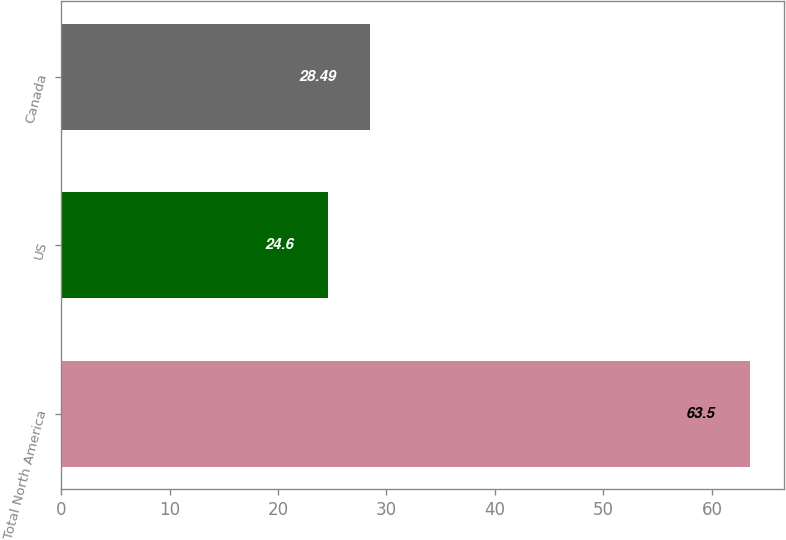Convert chart. <chart><loc_0><loc_0><loc_500><loc_500><bar_chart><fcel>Total North America<fcel>US<fcel>Canada<nl><fcel>63.5<fcel>24.6<fcel>28.49<nl></chart> 